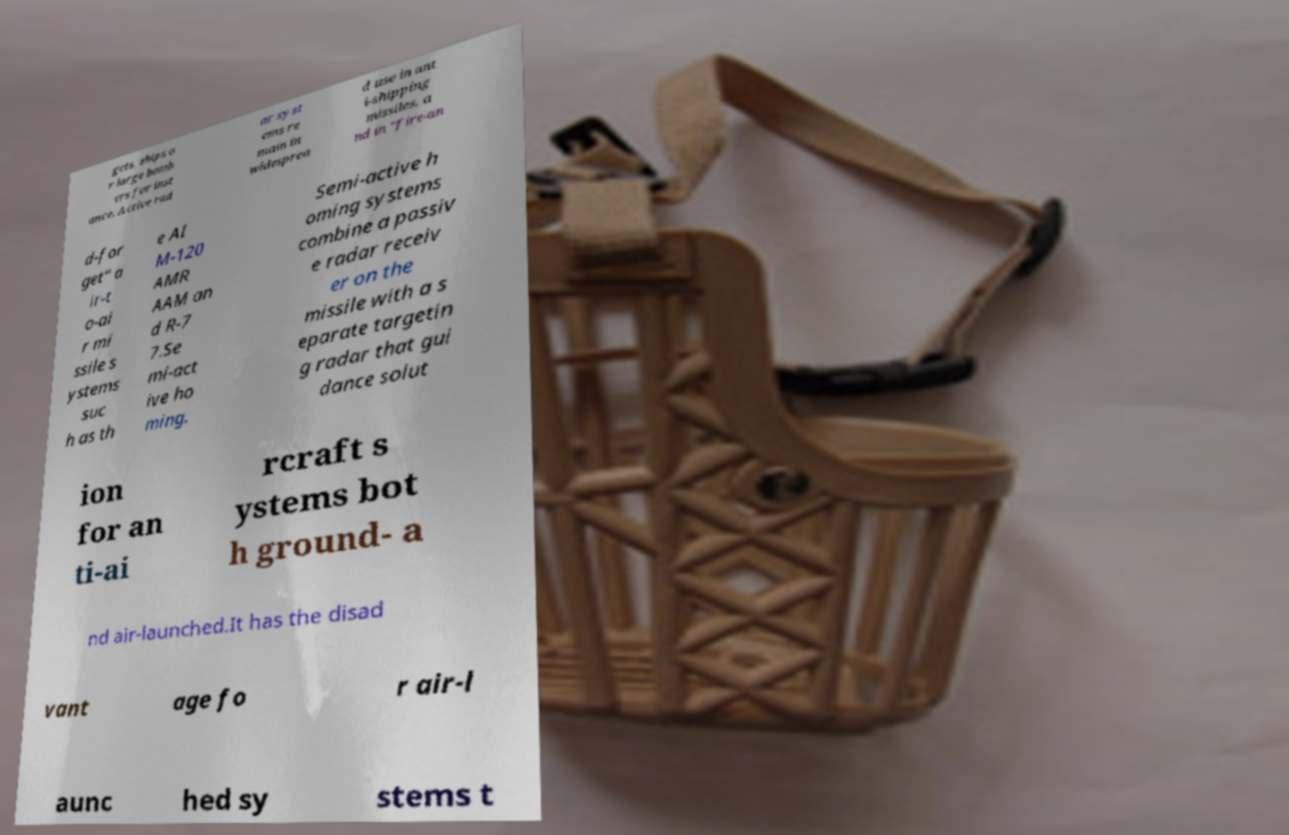Please identify and transcribe the text found in this image. gets, ships o r large bomb ers for inst ance. Active rad ar syst ems re main in widesprea d use in ant i-shipping missiles, a nd in "fire-an d-for get" a ir-t o-ai r mi ssile s ystems suc h as th e AI M-120 AMR AAM an d R-7 7.Se mi-act ive ho ming. Semi-active h oming systems combine a passiv e radar receiv er on the missile with a s eparate targetin g radar that gui dance solut ion for an ti-ai rcraft s ystems bot h ground- a nd air-launched.It has the disad vant age fo r air-l aunc hed sy stems t 